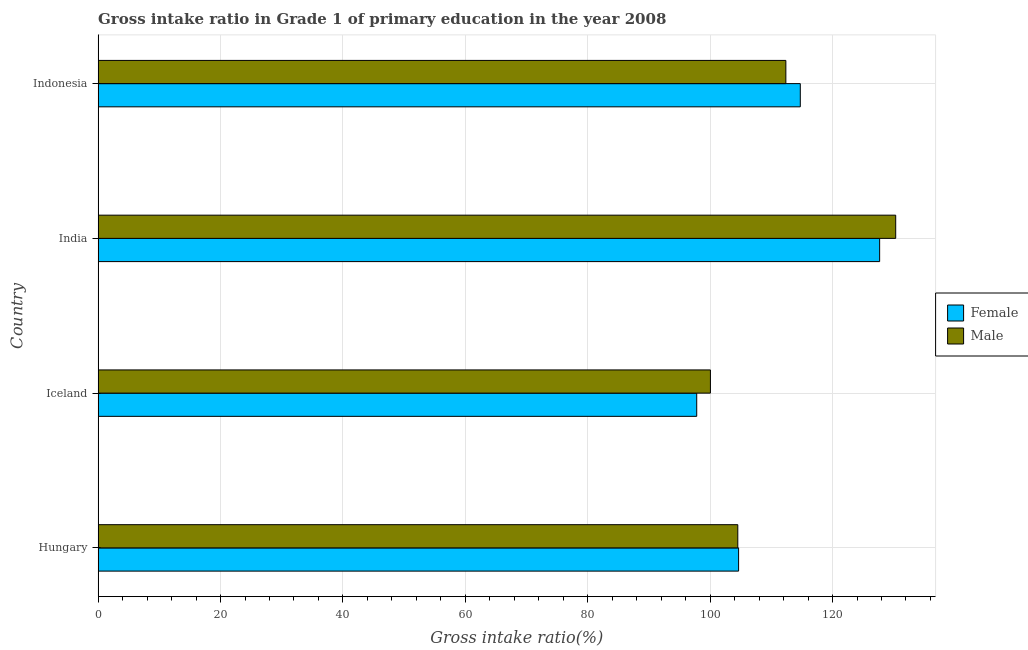How many groups of bars are there?
Provide a short and direct response. 4. How many bars are there on the 3rd tick from the top?
Provide a succinct answer. 2. What is the label of the 4th group of bars from the top?
Keep it short and to the point. Hungary. In how many cases, is the number of bars for a given country not equal to the number of legend labels?
Offer a very short reply. 0. What is the gross intake ratio(male) in Iceland?
Make the answer very short. 100.05. Across all countries, what is the maximum gross intake ratio(female)?
Provide a short and direct response. 127.7. Across all countries, what is the minimum gross intake ratio(male)?
Give a very brief answer. 100.05. In which country was the gross intake ratio(female) maximum?
Keep it short and to the point. India. What is the total gross intake ratio(female) in the graph?
Offer a terse response. 444.89. What is the difference between the gross intake ratio(male) in Iceland and that in India?
Ensure brevity in your answer.  -30.27. What is the difference between the gross intake ratio(male) in Iceland and the gross intake ratio(female) in Indonesia?
Keep it short and to the point. -14.68. What is the average gross intake ratio(female) per country?
Offer a terse response. 111.22. What is the difference between the gross intake ratio(male) and gross intake ratio(female) in Hungary?
Keep it short and to the point. -0.13. In how many countries, is the gross intake ratio(female) greater than 20 %?
Give a very brief answer. 4. What is the ratio of the gross intake ratio(female) in Hungary to that in Iceland?
Your response must be concise. 1.07. What is the difference between the highest and the second highest gross intake ratio(female)?
Your answer should be compact. 12.96. What is the difference between the highest and the lowest gross intake ratio(male)?
Ensure brevity in your answer.  30.27. In how many countries, is the gross intake ratio(female) greater than the average gross intake ratio(female) taken over all countries?
Offer a very short reply. 2. Is the sum of the gross intake ratio(male) in India and Indonesia greater than the maximum gross intake ratio(female) across all countries?
Provide a succinct answer. Yes. What does the 2nd bar from the bottom in Hungary represents?
Ensure brevity in your answer.  Male. How many bars are there?
Give a very brief answer. 8. Are all the bars in the graph horizontal?
Make the answer very short. Yes. How many countries are there in the graph?
Your answer should be very brief. 4. Are the values on the major ticks of X-axis written in scientific E-notation?
Your answer should be very brief. No. Does the graph contain any zero values?
Provide a succinct answer. No. Does the graph contain grids?
Offer a terse response. Yes. Where does the legend appear in the graph?
Your answer should be very brief. Center right. How are the legend labels stacked?
Ensure brevity in your answer.  Vertical. What is the title of the graph?
Give a very brief answer. Gross intake ratio in Grade 1 of primary education in the year 2008. What is the label or title of the X-axis?
Keep it short and to the point. Gross intake ratio(%). What is the label or title of the Y-axis?
Provide a short and direct response. Country. What is the Gross intake ratio(%) in Female in Hungary?
Offer a terse response. 104.65. What is the Gross intake ratio(%) in Male in Hungary?
Make the answer very short. 104.52. What is the Gross intake ratio(%) of Female in Iceland?
Make the answer very short. 97.81. What is the Gross intake ratio(%) of Male in Iceland?
Your answer should be compact. 100.05. What is the Gross intake ratio(%) of Female in India?
Offer a terse response. 127.7. What is the Gross intake ratio(%) of Male in India?
Keep it short and to the point. 130.32. What is the Gross intake ratio(%) of Female in Indonesia?
Make the answer very short. 114.73. What is the Gross intake ratio(%) of Male in Indonesia?
Offer a terse response. 112.37. Across all countries, what is the maximum Gross intake ratio(%) of Female?
Keep it short and to the point. 127.7. Across all countries, what is the maximum Gross intake ratio(%) in Male?
Ensure brevity in your answer.  130.32. Across all countries, what is the minimum Gross intake ratio(%) of Female?
Your response must be concise. 97.81. Across all countries, what is the minimum Gross intake ratio(%) of Male?
Your response must be concise. 100.05. What is the total Gross intake ratio(%) in Female in the graph?
Your answer should be very brief. 444.89. What is the total Gross intake ratio(%) of Male in the graph?
Ensure brevity in your answer.  447.26. What is the difference between the Gross intake ratio(%) of Female in Hungary and that in Iceland?
Offer a terse response. 6.84. What is the difference between the Gross intake ratio(%) in Male in Hungary and that in Iceland?
Your answer should be compact. 4.47. What is the difference between the Gross intake ratio(%) in Female in Hungary and that in India?
Your answer should be very brief. -23.05. What is the difference between the Gross intake ratio(%) of Male in Hungary and that in India?
Keep it short and to the point. -25.8. What is the difference between the Gross intake ratio(%) of Female in Hungary and that in Indonesia?
Your answer should be very brief. -10.08. What is the difference between the Gross intake ratio(%) in Male in Hungary and that in Indonesia?
Keep it short and to the point. -7.85. What is the difference between the Gross intake ratio(%) of Female in Iceland and that in India?
Offer a terse response. -29.89. What is the difference between the Gross intake ratio(%) of Male in Iceland and that in India?
Provide a succinct answer. -30.27. What is the difference between the Gross intake ratio(%) in Female in Iceland and that in Indonesia?
Offer a very short reply. -16.92. What is the difference between the Gross intake ratio(%) in Male in Iceland and that in Indonesia?
Provide a succinct answer. -12.33. What is the difference between the Gross intake ratio(%) of Female in India and that in Indonesia?
Offer a very short reply. 12.97. What is the difference between the Gross intake ratio(%) of Male in India and that in Indonesia?
Give a very brief answer. 17.95. What is the difference between the Gross intake ratio(%) of Female in Hungary and the Gross intake ratio(%) of Male in Iceland?
Your answer should be compact. 4.6. What is the difference between the Gross intake ratio(%) of Female in Hungary and the Gross intake ratio(%) of Male in India?
Your response must be concise. -25.67. What is the difference between the Gross intake ratio(%) of Female in Hungary and the Gross intake ratio(%) of Male in Indonesia?
Give a very brief answer. -7.72. What is the difference between the Gross intake ratio(%) in Female in Iceland and the Gross intake ratio(%) in Male in India?
Offer a terse response. -32.51. What is the difference between the Gross intake ratio(%) in Female in Iceland and the Gross intake ratio(%) in Male in Indonesia?
Your response must be concise. -14.57. What is the difference between the Gross intake ratio(%) of Female in India and the Gross intake ratio(%) of Male in Indonesia?
Give a very brief answer. 15.32. What is the average Gross intake ratio(%) in Female per country?
Your answer should be compact. 111.22. What is the average Gross intake ratio(%) in Male per country?
Offer a terse response. 111.82. What is the difference between the Gross intake ratio(%) of Female and Gross intake ratio(%) of Male in Hungary?
Offer a terse response. 0.13. What is the difference between the Gross intake ratio(%) in Female and Gross intake ratio(%) in Male in Iceland?
Provide a short and direct response. -2.24. What is the difference between the Gross intake ratio(%) in Female and Gross intake ratio(%) in Male in India?
Make the answer very short. -2.62. What is the difference between the Gross intake ratio(%) in Female and Gross intake ratio(%) in Male in Indonesia?
Offer a terse response. 2.36. What is the ratio of the Gross intake ratio(%) of Female in Hungary to that in Iceland?
Offer a very short reply. 1.07. What is the ratio of the Gross intake ratio(%) of Male in Hungary to that in Iceland?
Ensure brevity in your answer.  1.04. What is the ratio of the Gross intake ratio(%) of Female in Hungary to that in India?
Make the answer very short. 0.82. What is the ratio of the Gross intake ratio(%) of Male in Hungary to that in India?
Provide a short and direct response. 0.8. What is the ratio of the Gross intake ratio(%) in Female in Hungary to that in Indonesia?
Ensure brevity in your answer.  0.91. What is the ratio of the Gross intake ratio(%) in Male in Hungary to that in Indonesia?
Provide a short and direct response. 0.93. What is the ratio of the Gross intake ratio(%) in Female in Iceland to that in India?
Ensure brevity in your answer.  0.77. What is the ratio of the Gross intake ratio(%) in Male in Iceland to that in India?
Ensure brevity in your answer.  0.77. What is the ratio of the Gross intake ratio(%) in Female in Iceland to that in Indonesia?
Provide a short and direct response. 0.85. What is the ratio of the Gross intake ratio(%) of Male in Iceland to that in Indonesia?
Your answer should be very brief. 0.89. What is the ratio of the Gross intake ratio(%) in Female in India to that in Indonesia?
Your answer should be very brief. 1.11. What is the ratio of the Gross intake ratio(%) of Male in India to that in Indonesia?
Give a very brief answer. 1.16. What is the difference between the highest and the second highest Gross intake ratio(%) in Female?
Your answer should be very brief. 12.97. What is the difference between the highest and the second highest Gross intake ratio(%) in Male?
Make the answer very short. 17.95. What is the difference between the highest and the lowest Gross intake ratio(%) of Female?
Offer a very short reply. 29.89. What is the difference between the highest and the lowest Gross intake ratio(%) in Male?
Offer a very short reply. 30.27. 